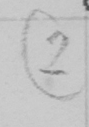What is written in this line of handwriting? ( 2 